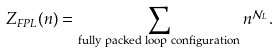Convert formula to latex. <formula><loc_0><loc_0><loc_500><loc_500>Z _ { F P L } ( n ) = \sum _ { \text {fully packed loop configuration} } n ^ { \mathcal { N } _ { L } } .</formula> 